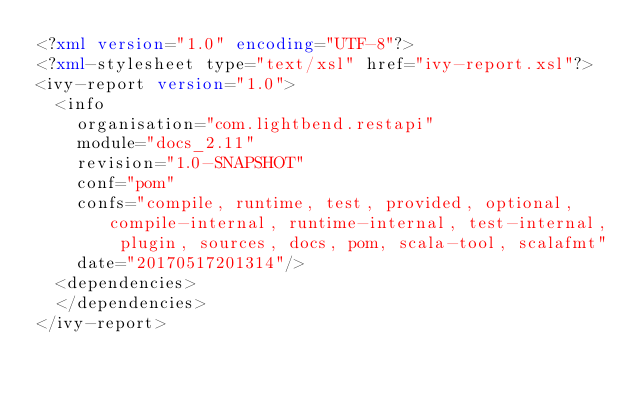<code> <loc_0><loc_0><loc_500><loc_500><_XML_><?xml version="1.0" encoding="UTF-8"?>
<?xml-stylesheet type="text/xsl" href="ivy-report.xsl"?>
<ivy-report version="1.0">
	<info
		organisation="com.lightbend.restapi"
		module="docs_2.11"
		revision="1.0-SNAPSHOT"
		conf="pom"
		confs="compile, runtime, test, provided, optional, compile-internal, runtime-internal, test-internal, plugin, sources, docs, pom, scala-tool, scalafmt"
		date="20170517201314"/>
	<dependencies>
	</dependencies>
</ivy-report>
</code> 